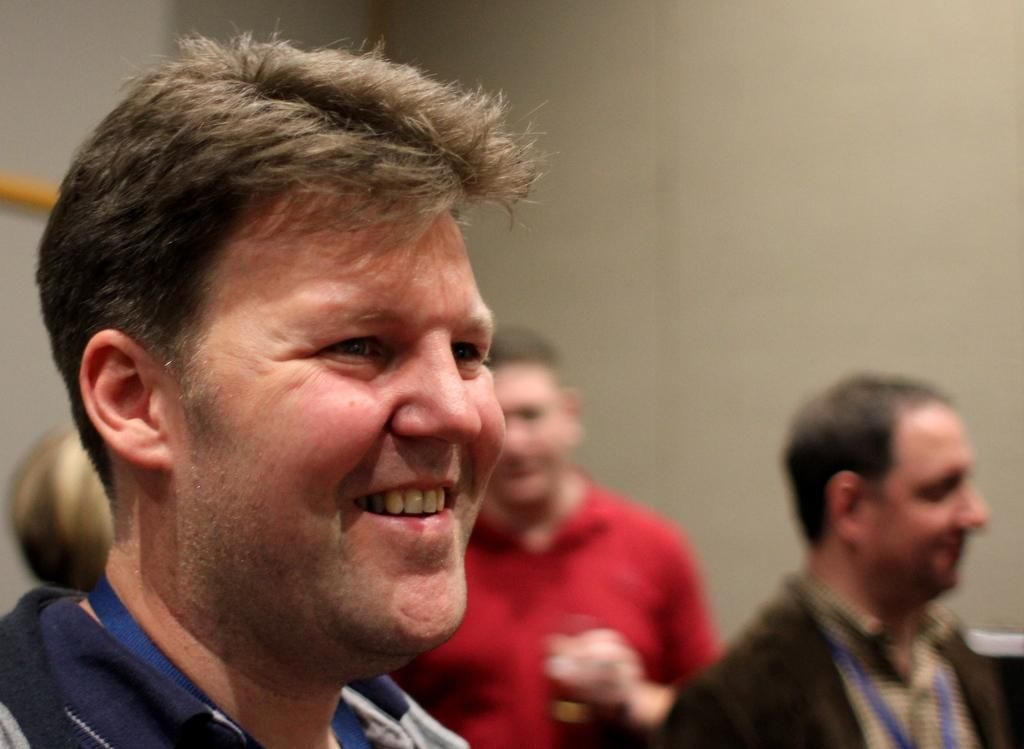Who or what is present in the image? There are people in the image. What is the facial expression of the people in the image? The people in the image are smiling. What can be seen in the background of the image? There is a wall in the background of the image. How many chickens are visible in the image? There are no chickens present in the image. What type of rabbit can be seen interacting with the people in the image? There is no rabbit present in the image; only people are visible. 